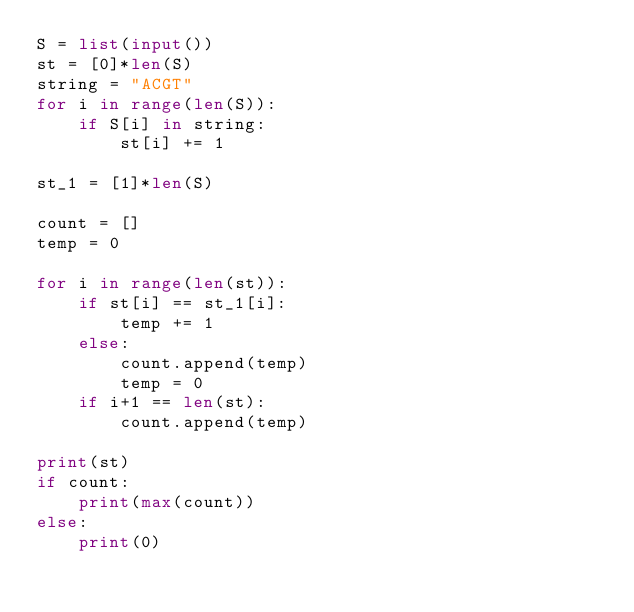<code> <loc_0><loc_0><loc_500><loc_500><_Python_>S = list(input())
st = [0]*len(S)
string = "ACGT"
for i in range(len(S)):
    if S[i] in string:
        st[i] += 1

st_1 = [1]*len(S)

count = []
temp = 0

for i in range(len(st)):
    if st[i] == st_1[i]:
        temp += 1
    else:
        count.append(temp)
        temp = 0
    if i+1 == len(st):
        count.append(temp)
        
print(st)
if count:
    print(max(count))
else:
    print(0)</code> 